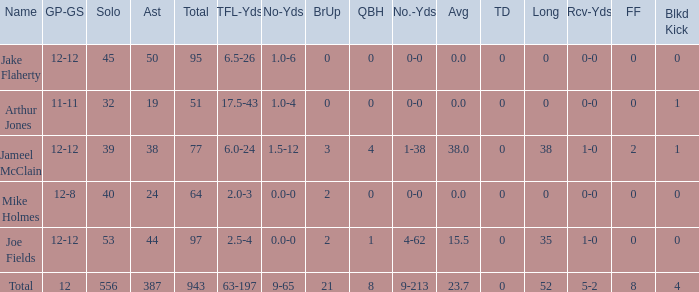How many players named jake flaherty? 1.0. 